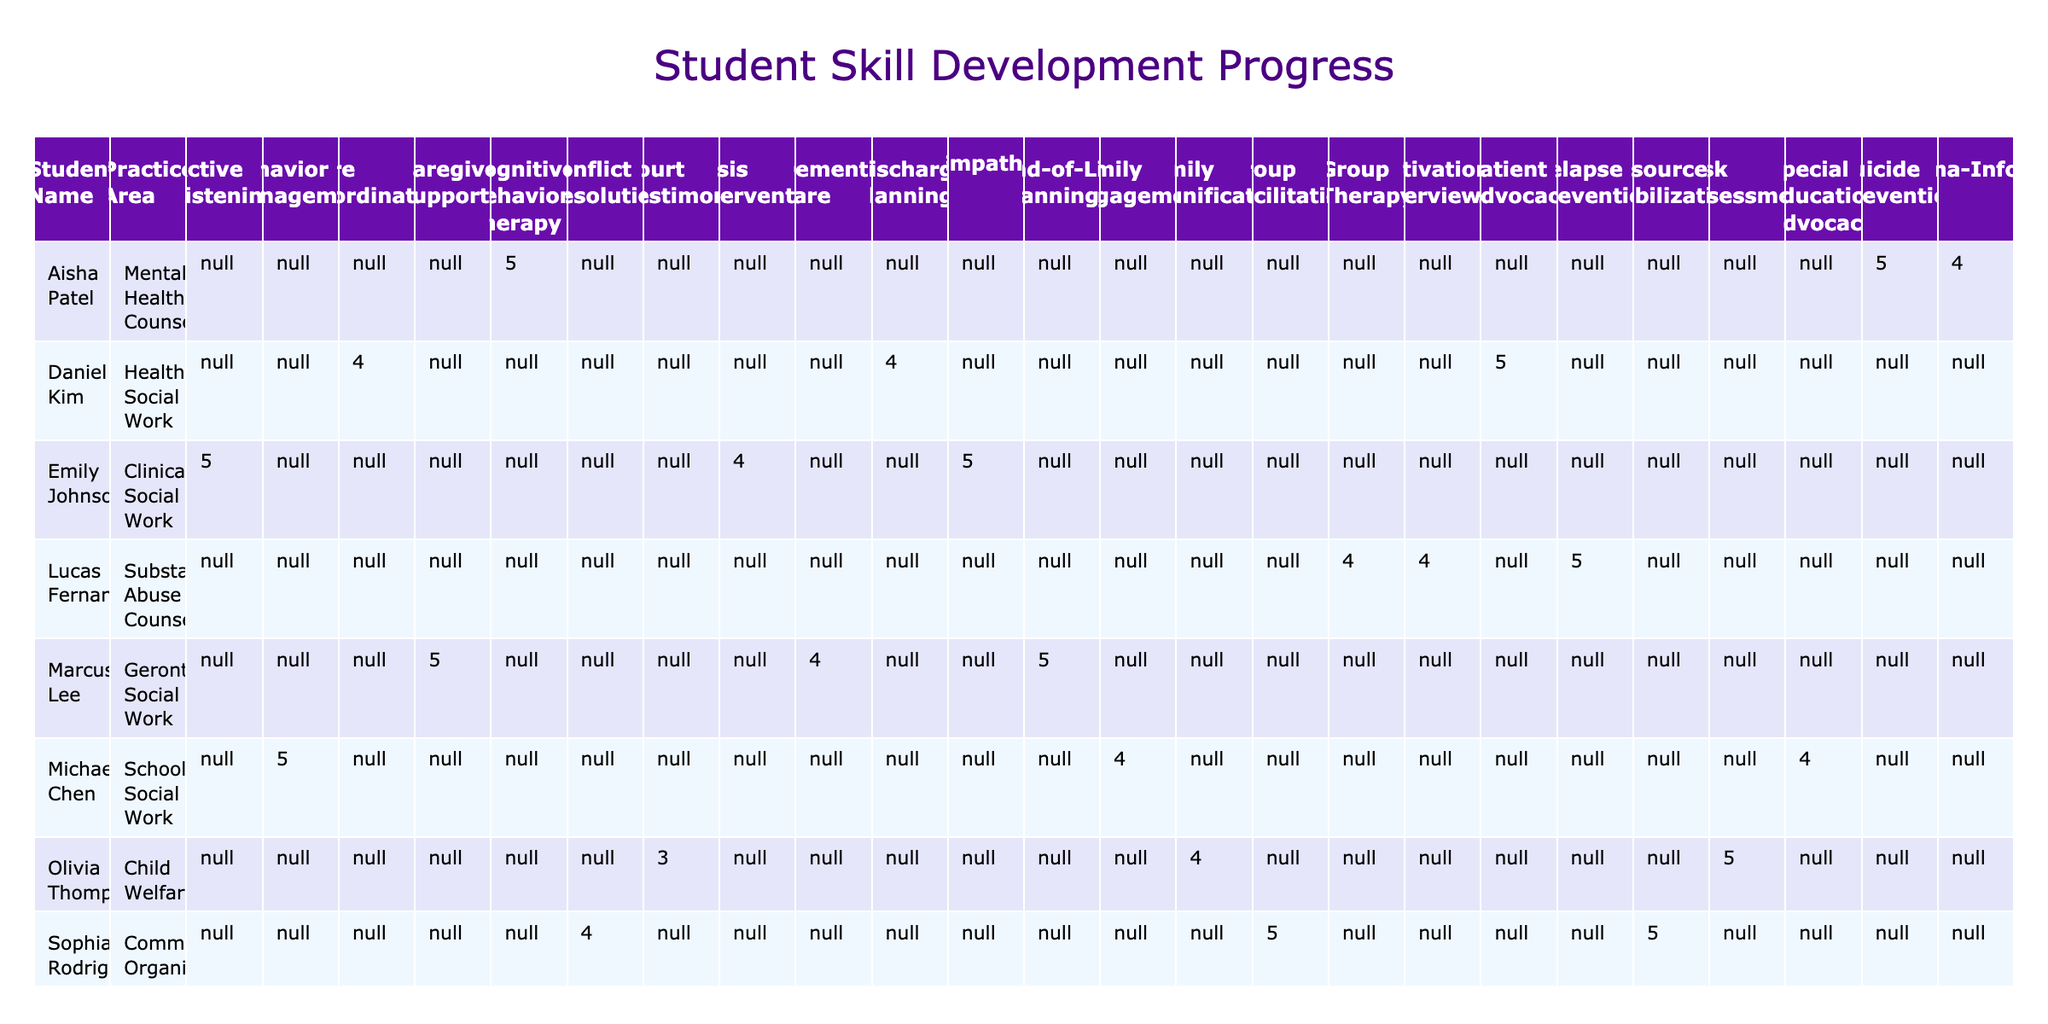What is the final assessment score for Emily Johnson in Crisis Intervention? In the table, under Emily Johnson's row and the Crisis Intervention skill column, the Final Assessment score is listed as 4.
Answer: 4 Which student showed the greatest improvement in Final Assessment scores across all skills? To determine the greatest improvement, look at the difference between Initial and Final Assessment scores for each skill. Emily Johnson has improvements of 3, 1, and 2 points for her skills, totaling a maximum improvement of 3 points in Active Listening. Michael Chen improved by 3 points in Behavior Management. Olivia Thompson showed a maximum of 2 points improvement in Court Testimony. Therefore, Michael Chen and Emily Johnson both show the maximum improvement of 3 points.
Answer: Michael Chen and Emily Johnson Is the final assessment score for Olivia Thompson's Court Testimony greater than 2? The final assessment score for Court Testimony under Olivia Thompson is 3, which is indeed greater than 2.
Answer: Yes What is the average Final Assessment score for each Practice Area? To find the average for each Practice Area, sum all the Final Assessment scores and divide by the number of scores for that area: Clinical Social Work (5+5+4)/3 = 4.67; School Social Work (5+4+4)/3 = 4.33; Community Organizing (5+4+5)/3 = 4.67; Healthcare Social Work (4+5+4)/3 = 4.33; Child Welfare (5+4+3)/3 = 4; Gerontological Social Work (4+5+5)/3 = 4.67; Mental Health Counseling (5+4+5)/3 = 4.67; Substance Abuse Counseling (4+5+4)/3 = 4.33.
Answer: Clinical Social Work: 4.67, School Social Work: 4.33, Community Organizing: 4.67, Healthcare Social Work: 4.33, Child Welfare: 4, Gerontological Social Work: 4.67, Mental Health Counseling: 4.67, Substance Abuse Counseling: 4.33 Did any student receive a final assessment score of 5 in all their skills? By checking each student's final assessment scores, none of the students achieved a score of 5 across all their skills. The closest was Emily Johnson, who received a score of 5 in two skills but not all three.
Answer: No 